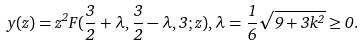Convert formula to latex. <formula><loc_0><loc_0><loc_500><loc_500>y ( z ) = z ^ { 2 } F ( \frac { 3 } { 2 } + \lambda , \frac { 3 } { 2 } - \lambda , 3 ; z ) , \lambda = \frac { 1 } { 6 } \sqrt { 9 + 3 k ^ { 2 } } \geq 0 .</formula> 